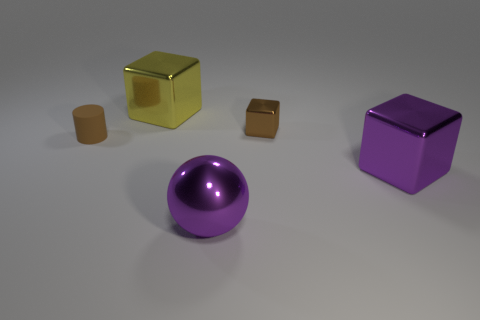Subtract all big metallic blocks. How many blocks are left? 1 Add 3 small metallic blocks. How many objects exist? 8 Subtract all brown cubes. How many cubes are left? 2 Subtract 1 cubes. How many cubes are left? 2 Subtract all cylinders. How many objects are left? 4 Subtract all red blocks. Subtract all green cylinders. How many blocks are left? 3 Subtract all yellow balls. How many blue cylinders are left? 0 Subtract all tiny metal blocks. Subtract all tiny cylinders. How many objects are left? 3 Add 4 small brown cylinders. How many small brown cylinders are left? 5 Add 4 small green shiny spheres. How many small green shiny spheres exist? 4 